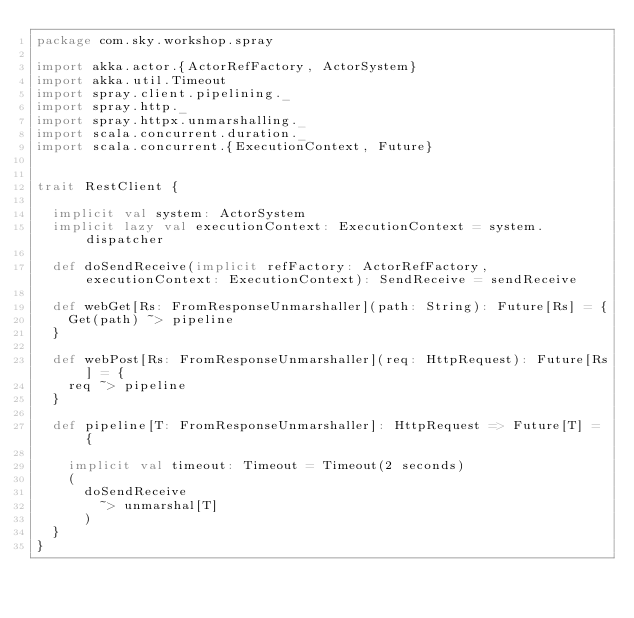Convert code to text. <code><loc_0><loc_0><loc_500><loc_500><_Scala_>package com.sky.workshop.spray

import akka.actor.{ActorRefFactory, ActorSystem}
import akka.util.Timeout
import spray.client.pipelining._
import spray.http._
import spray.httpx.unmarshalling._
import scala.concurrent.duration._
import scala.concurrent.{ExecutionContext, Future}


trait RestClient {

  implicit val system: ActorSystem
  implicit lazy val executionContext: ExecutionContext = system.dispatcher

  def doSendReceive(implicit refFactory: ActorRefFactory, executionContext: ExecutionContext): SendReceive = sendReceive

  def webGet[Rs: FromResponseUnmarshaller](path: String): Future[Rs] = {
    Get(path) ~> pipeline
  }

  def webPost[Rs: FromResponseUnmarshaller](req: HttpRequest): Future[Rs] = {
    req ~> pipeline
  }

  def pipeline[T: FromResponseUnmarshaller]: HttpRequest => Future[T] = {

    implicit val timeout: Timeout = Timeout(2 seconds)
    (
      doSendReceive
        ~> unmarshal[T]
      )
  }
}
</code> 